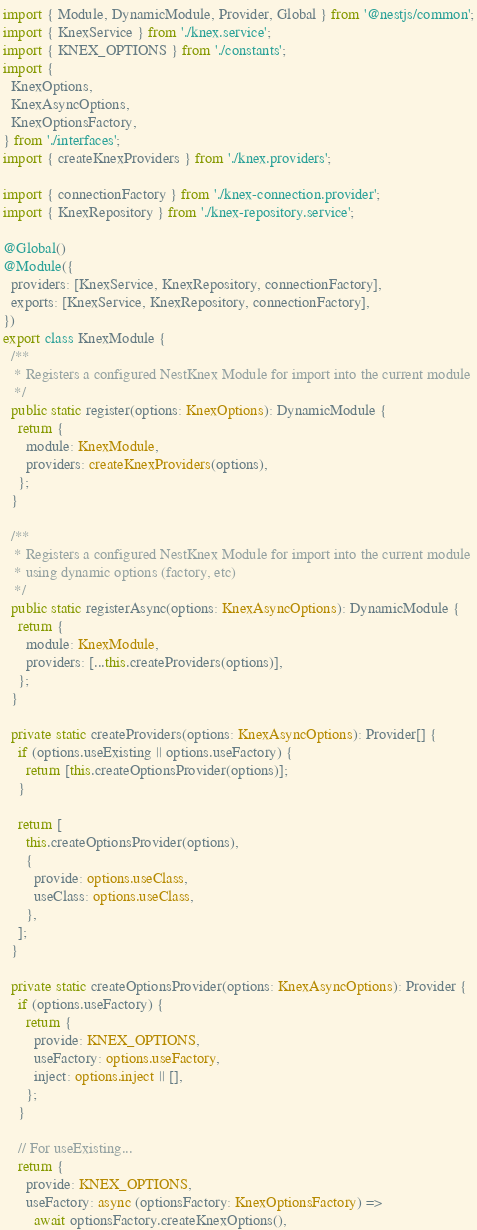Convert code to text. <code><loc_0><loc_0><loc_500><loc_500><_TypeScript_>import { Module, DynamicModule, Provider, Global } from '@nestjs/common';
import { KnexService } from './knex.service';
import { KNEX_OPTIONS } from './constants';
import {
  KnexOptions,
  KnexAsyncOptions,
  KnexOptionsFactory,
} from './interfaces';
import { createKnexProviders } from './knex.providers';

import { connectionFactory } from './knex-connection.provider';
import { KnexRepository } from './knex-repository.service';

@Global()
@Module({
  providers: [KnexService, KnexRepository, connectionFactory],
  exports: [KnexService, KnexRepository, connectionFactory],
})
export class KnexModule {
  /**
   * Registers a configured NestKnex Module for import into the current module
   */
  public static register(options: KnexOptions): DynamicModule {
    return {
      module: KnexModule,
      providers: createKnexProviders(options),
    };
  }

  /**
   * Registers a configured NestKnex Module for import into the current module
   * using dynamic options (factory, etc)
   */
  public static registerAsync(options: KnexAsyncOptions): DynamicModule {
    return {
      module: KnexModule,
      providers: [...this.createProviders(options)],
    };
  }

  private static createProviders(options: KnexAsyncOptions): Provider[] {
    if (options.useExisting || options.useFactory) {
      return [this.createOptionsProvider(options)];
    }

    return [
      this.createOptionsProvider(options),
      {
        provide: options.useClass,
        useClass: options.useClass,
      },
    ];
  }

  private static createOptionsProvider(options: KnexAsyncOptions): Provider {
    if (options.useFactory) {
      return {
        provide: KNEX_OPTIONS,
        useFactory: options.useFactory,
        inject: options.inject || [],
      };
    }

    // For useExisting...
    return {
      provide: KNEX_OPTIONS,
      useFactory: async (optionsFactory: KnexOptionsFactory) =>
        await optionsFactory.createKnexOptions(),</code> 